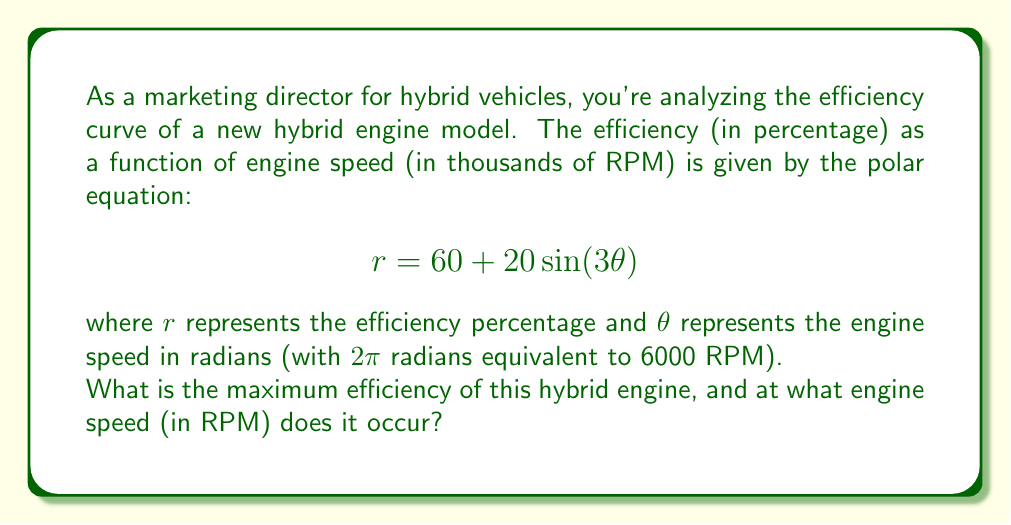What is the answer to this math problem? To solve this problem, we need to follow these steps:

1) The maximum efficiency will occur at the maximum value of $r$. In a polar equation of the form $r = a + b\sin(n\theta)$, the maximum value occurs when $\sin(n\theta) = 1$.

2) In our equation, $r = 60 + 20\sin(3\theta)$, the maximum $r$ will occur when $\sin(3\theta) = 1$.

3) The maximum efficiency is therefore:
   $$r_{max} = 60 + 20(1) = 80\%$$

4) To find the engine speed at which this occurs, we need to solve:
   $$\sin(3\theta) = 1$$

5) This occurs when $3\theta = \frac{\pi}{2}, \frac{5\pi}{2}, \frac{9\pi}{2}$, etc. The smallest positive value is:
   $$3\theta = \frac{\pi}{2}$$
   $$\theta = \frac{\pi}{6} \approx 0.5236 \text{ radians}$$

6) We need to convert this to RPM. We know that $2\pi$ radians is equivalent to 6000 RPM. So:
   $$\frac{\theta}{2\pi} = \frac{\text{RPM}}{6000}$$
   $$\text{RPM} = \frac{6000 \theta}{2\pi} = \frac{6000 \cdot \frac{\pi}{6}}{2\pi} = 500 \text{ RPM}$$

Therefore, the maximum efficiency occurs at 500 RPM.
Answer: The maximum efficiency is 80%, occurring at an engine speed of 500 RPM. 